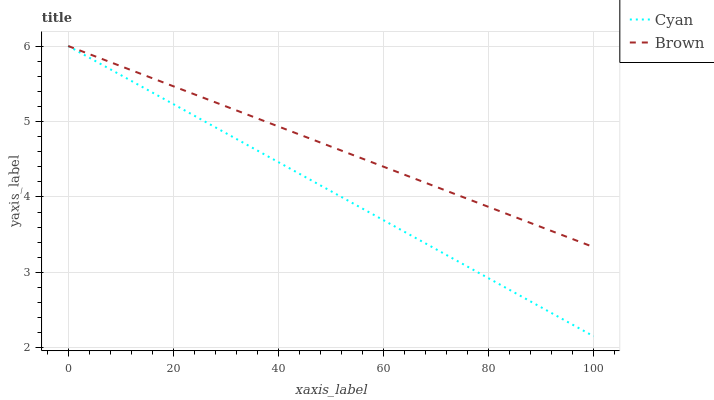Does Cyan have the minimum area under the curve?
Answer yes or no. Yes. Does Brown have the minimum area under the curve?
Answer yes or no. No. Is Cyan the roughest?
Answer yes or no. Yes. Is Brown the roughest?
Answer yes or no. No. Does Brown have the lowest value?
Answer yes or no. No. 